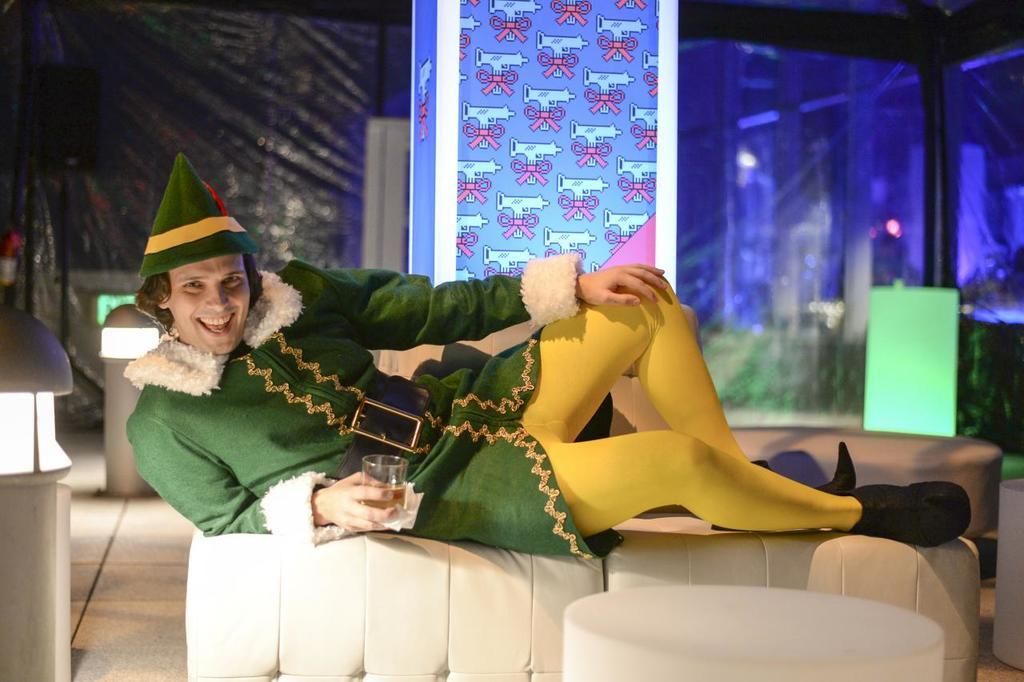Who is present in the image? There is a man in the image. What is the man doing in the image? The man is lying on a sofa. What is the man holding in his hand? The man is holding a beverage tumbler in his hand. What can be seen in the background of the image? There are electric lights and a curtain in the background of the image. What is the slope of the hill in the image? There is no hill or slope present in the image; it features a man lying on a sofa. What year is depicted in the image? The image does not depict a specific year; it is a snapshot of a man lying on a sofa. 